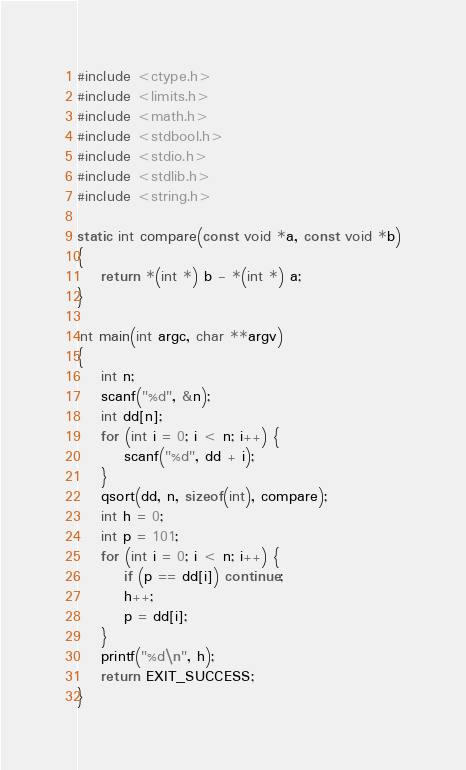Convert code to text. <code><loc_0><loc_0><loc_500><loc_500><_C_>#include <ctype.h>
#include <limits.h>
#include <math.h>
#include <stdbool.h>
#include <stdio.h>
#include <stdlib.h>
#include <string.h>

static int compare(const void *a, const void *b)
{
    return *(int *) b - *(int *) a;
}

int main(int argc, char **argv)
{
    int n;
    scanf("%d", &n);
    int dd[n];
    for (int i = 0; i < n; i++) {
        scanf("%d", dd + i);
    }
    qsort(dd, n, sizeof(int), compare);
    int h = 0;
    int p = 101;
    for (int i = 0; i < n; i++) {
        if (p == dd[i]) continue;
        h++;
        p = dd[i];
    }
    printf("%d\n", h);
    return EXIT_SUCCESS;
}
</code> 